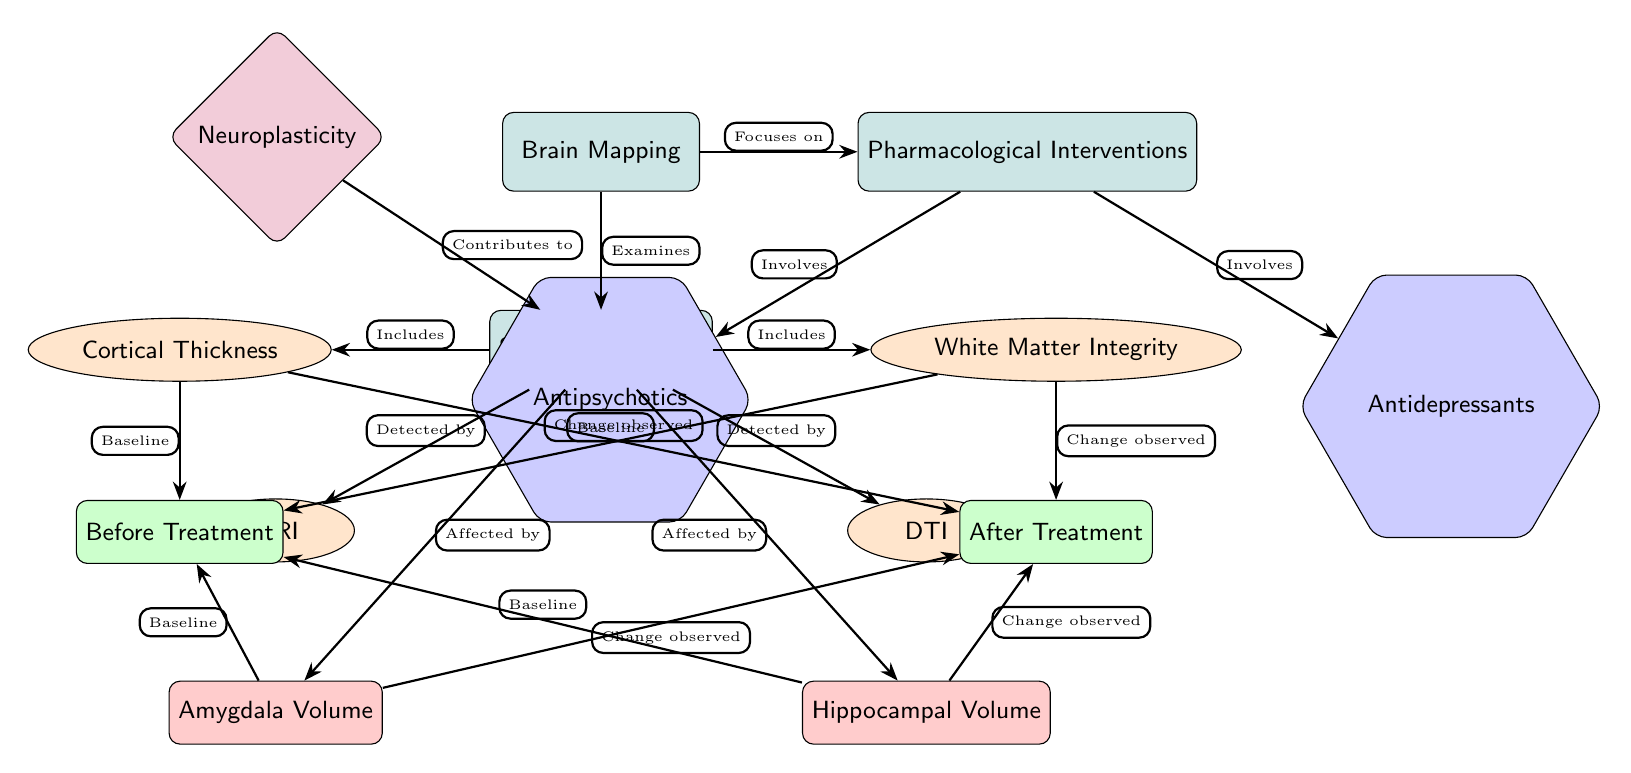what does brain mapping examine? The diagram indicates that brain mapping examines structural changes, as shown by the arrow connecting "Brain Mapping" to "Structural Changes."
Answer: Structural Changes what are the two types of pharmacological interventions listed? The diagram displays two types of pharmacological interventions connected to "Pharmacological Interventions": "Antidepressants" and "Antipsychotics."
Answer: Antidepressants, Antipsychotics which node shows the baseline for cortical thickness? The baseline for cortical thickness is indicated by the connection from "Cortical Thickness" to "Before Treatment," which denotes the starting point before any pharmacological intervention.
Answer: Before Treatment what two brain areas are affected by structural changes? Structural changes affect the "Amygdala Volume" and "Hippocampal Volume," as represented by the arrows from "Structural Changes" to these two areas in the diagram.
Answer: Amygdala Volume, Hippocampal Volume how does neuroplasticity relate to structural changes? The diagram shows a connection from "Neuroplasticity" to "Structural Changes," indicating that neuroplasticity contributes to the changes observed in the brain structure.
Answer: Contributes to after treatment, what type of change is observed in white matter integrity? According to the diagram, a change is observed in "White Matter Integrity" after treatment, as indicated by the arrow connecting "White Matter Integrity" to "After Treatment."
Answer: Change observed how is cortical thickness detected? The diagram specifies that cortical thickness is detected by "MRI," which is connected to the "Structural Changes" node with an arrow labeled "Detected by."
Answer: MRI how many main nodes are there in the diagram? The diagram features three main nodes: "Brain Mapping," "Structural Changes," and "Pharmacological Interventions," thus totaling three main nodes.
Answer: 3 which node represents the structural change detected by DTI? The structural change detected by DTI is represented by the node "DTI," which is linked to "Structural Changes" with the label "Detected by."
Answer: DTI 